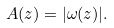<formula> <loc_0><loc_0><loc_500><loc_500>A ( z ) = | \omega ( z ) | .</formula> 